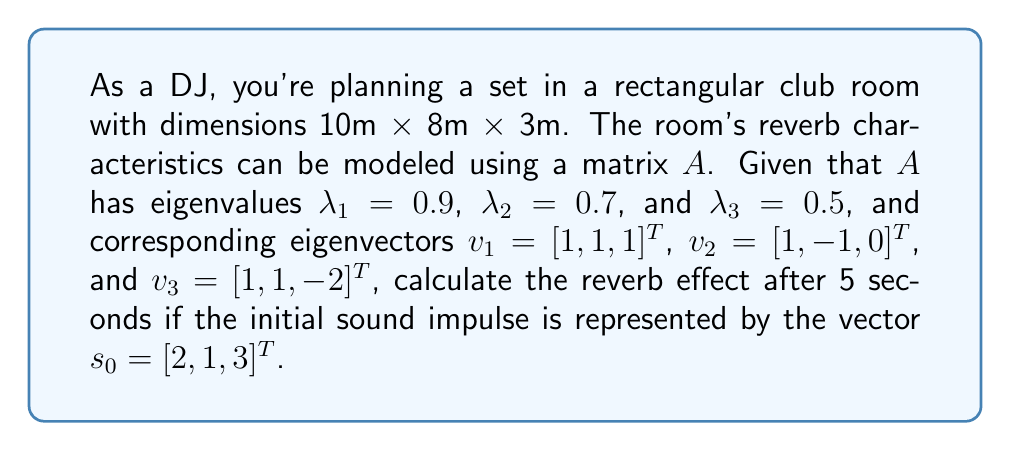Solve this math problem. To solve this problem, we'll use the eigenvector decomposition method to compute the reverb effect. Here's a step-by-step approach:

1) First, we need to express the initial sound impulse $s_0$ as a linear combination of the eigenvectors:

   $s_0 = c_1v_1 + c_2v_2 + c_3v_3$

2) To find the coefficients $c_1$, $c_2$, and $c_3$, we solve the system of equations:

   $$\begin{bmatrix}
   1 & 1 & 1 \\
   1 & -1 & 1 \\
   1 & 0 & -2
   \end{bmatrix}
   \begin{bmatrix}
   c_1 \\ c_2 \\ c_3
   \end{bmatrix} =
   \begin{bmatrix}
   2 \\ 1 \\ 3
   \end{bmatrix}$$

3) Solving this system (you can use Gaussian elimination or matrix inversion), we get:
   
   $c_1 = 1.5$, $c_2 = 0.5$, $c_3 = 0$

4) Now, we can express the sound after time $t$ as:

   $s(t) = c_1\lambda_1^tv_1 + c_2\lambda_2^tv_2 + c_3\lambda_3^tv_3$

5) For $t = 5$ seconds:

   $s(5) = 1.5(0.9)^5[1, 1, 1]^T + 0.5(0.7)^5[1, -1, 0]^T + 0(0.5)^5[1, 1, -2]^T$

6) Calculating the powers:
   $(0.9)^5 \approx 0.5905$
   $(0.7)^5 \approx 0.1681$

7) Substituting these values:

   $s(5) = 1.5(0.5905)[1, 1, 1]^T + 0.5(0.1681)[1, -1, 0]^T$

8) Simplifying:

   $s(5) = [0.8858, 0.8858, 0.8858]^T + [0.0841, -0.0841, 0]^T$

9) Adding these vectors:

   $s(5) = [0.9699, 0.8017, 0.8858]^T$

This vector represents the reverb effect after 5 seconds.
Answer: The reverb effect after 5 seconds is represented by the vector $s(5) = [0.9699, 0.8017, 0.8858]^T$. 